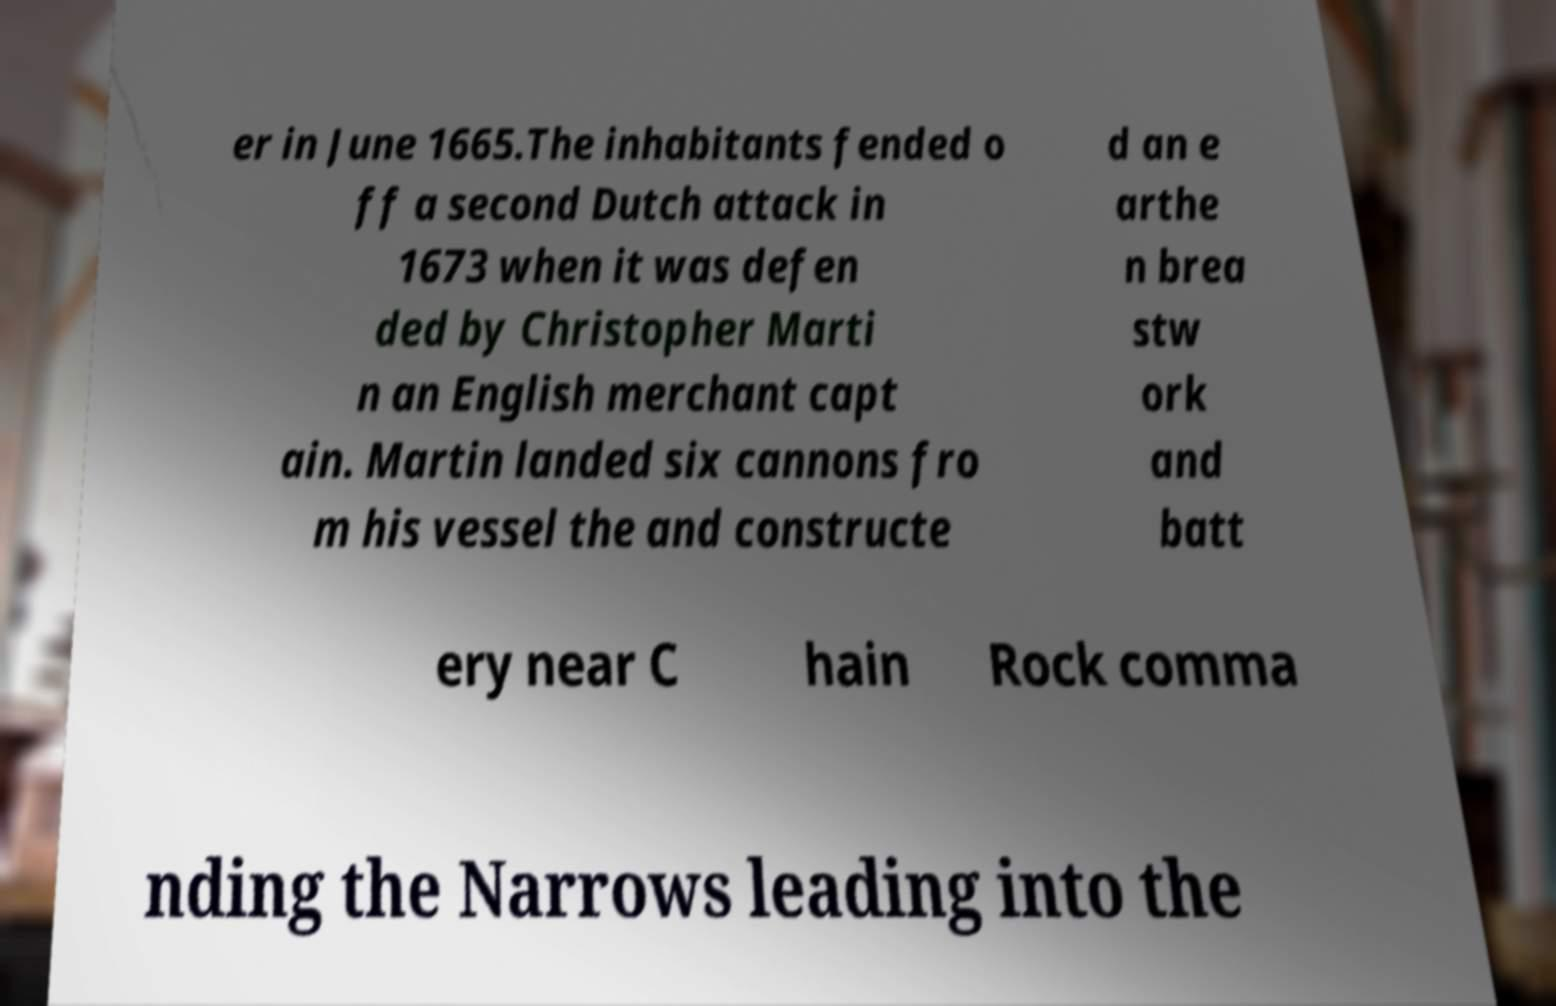Please read and relay the text visible in this image. What does it say? er in June 1665.The inhabitants fended o ff a second Dutch attack in 1673 when it was defen ded by Christopher Marti n an English merchant capt ain. Martin landed six cannons fro m his vessel the and constructe d an e arthe n brea stw ork and batt ery near C hain Rock comma nding the Narrows leading into the 